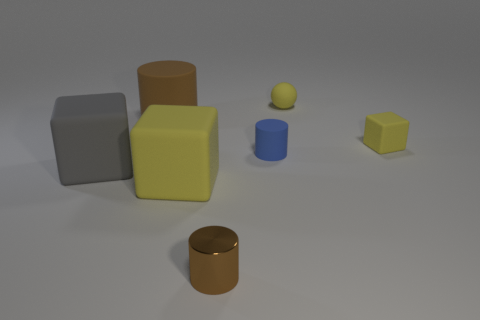Subtract 1 cylinders. How many cylinders are left? 2 Add 3 gray blocks. How many objects exist? 10 Subtract all brown cylinders. How many cylinders are left? 1 Subtract all small rubber cylinders. How many cylinders are left? 2 Subtract all rubber blocks. Subtract all blue rubber cubes. How many objects are left? 4 Add 2 big cubes. How many big cubes are left? 4 Add 7 large purple matte cylinders. How many large purple matte cylinders exist? 7 Subtract 0 red balls. How many objects are left? 7 Subtract all blocks. How many objects are left? 4 Subtract all brown cylinders. Subtract all cyan spheres. How many cylinders are left? 1 